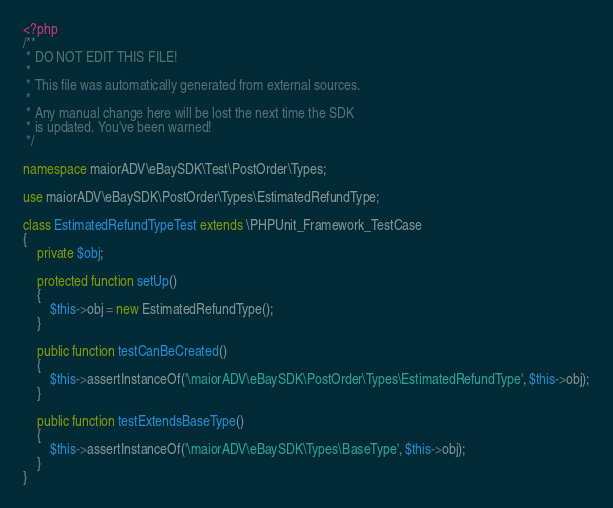Convert code to text. <code><loc_0><loc_0><loc_500><loc_500><_PHP_><?php
/**
 * DO NOT EDIT THIS FILE!
 *
 * This file was automatically generated from external sources.
 *
 * Any manual change here will be lost the next time the SDK
 * is updated. You've been warned!
 */

namespace maiorADV\eBaySDK\Test\PostOrder\Types;

use maiorADV\eBaySDK\PostOrder\Types\EstimatedRefundType;

class EstimatedRefundTypeTest extends \PHPUnit_Framework_TestCase
{
    private $obj;

    protected function setUp()
    {
        $this->obj = new EstimatedRefundType();
    }

    public function testCanBeCreated()
    {
        $this->assertInstanceOf('\maiorADV\eBaySDK\PostOrder\Types\EstimatedRefundType', $this->obj);
    }

    public function testExtendsBaseType()
    {
        $this->assertInstanceOf('\maiorADV\eBaySDK\Types\BaseType', $this->obj);
    }
}
</code> 